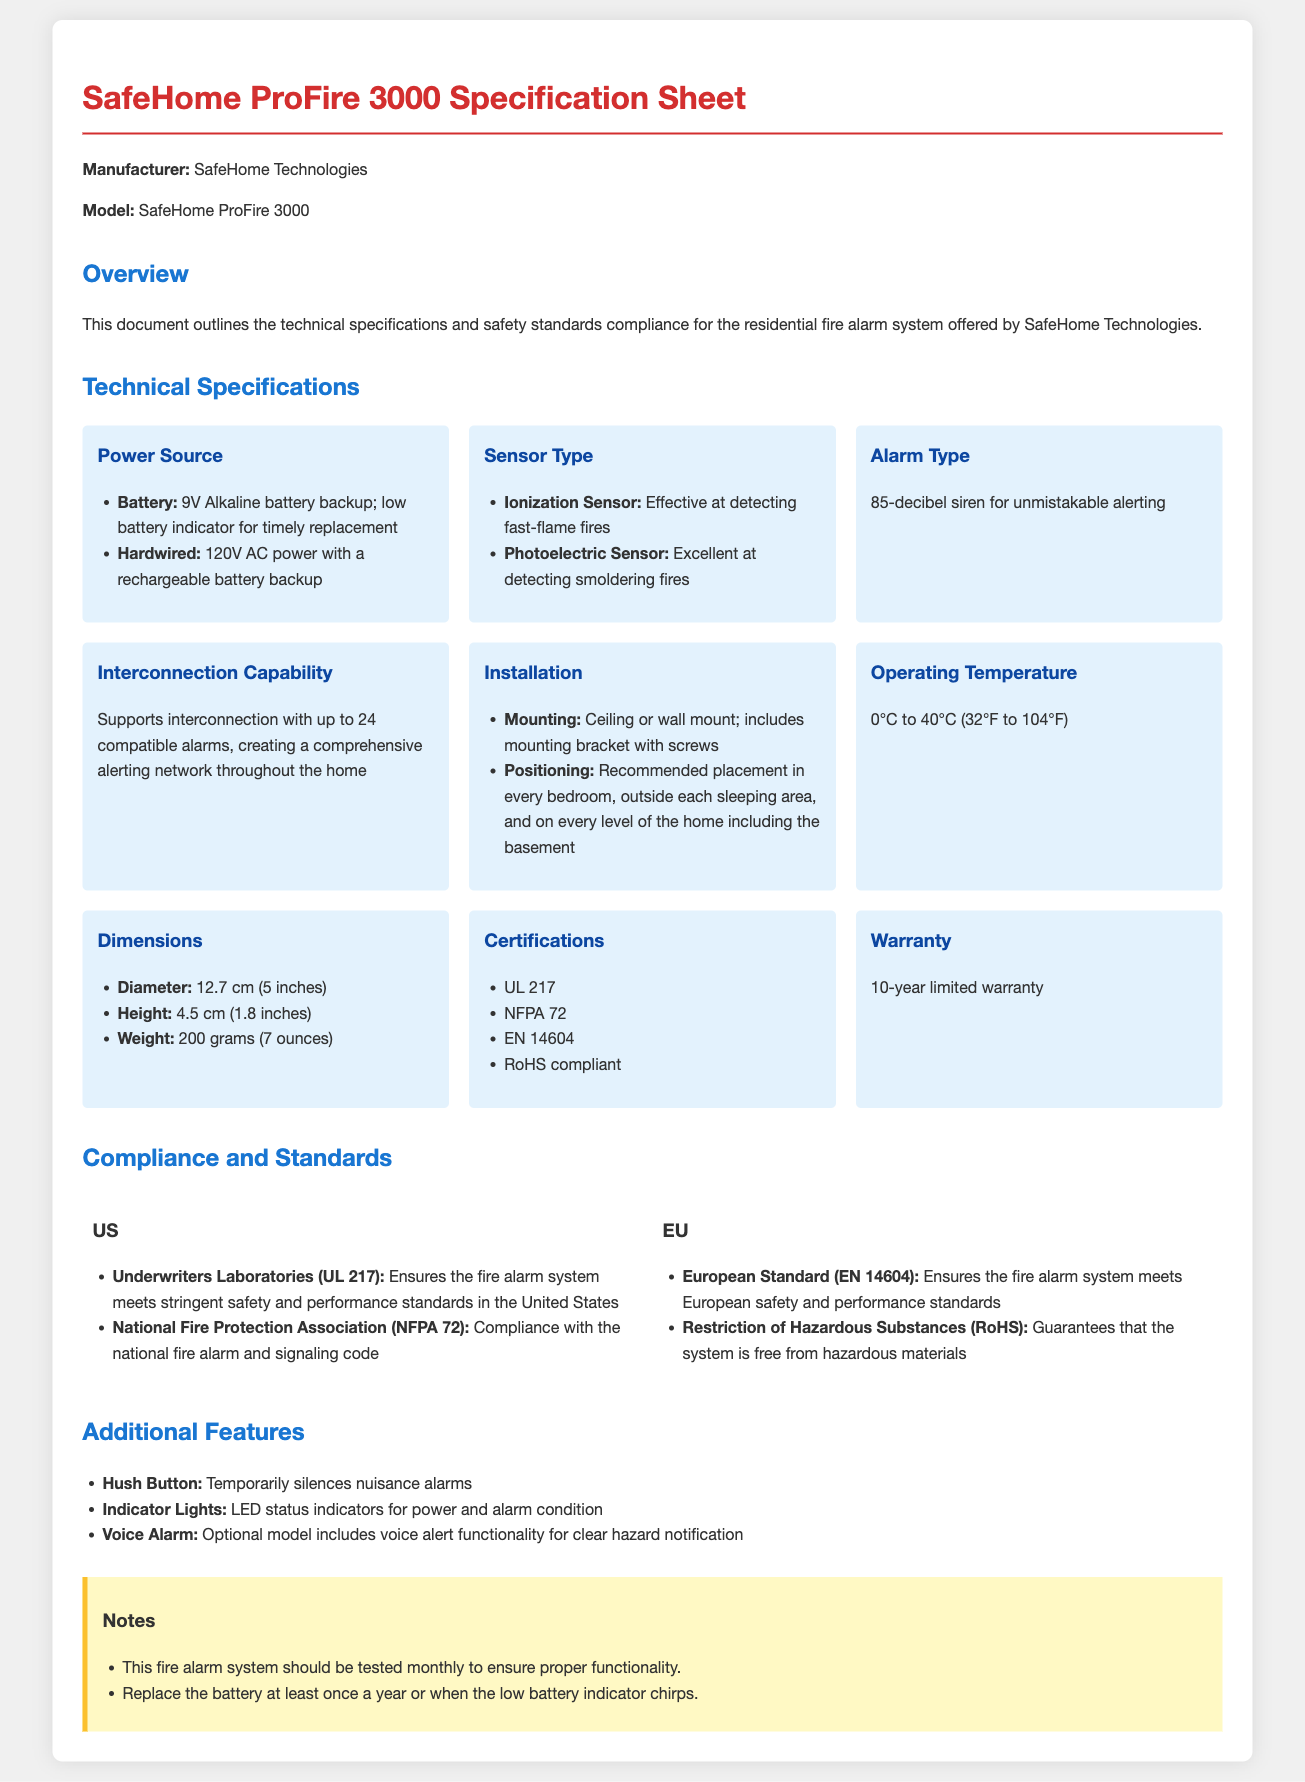What is the model name of the fire alarm system? The model name of the fire alarm system is found in the title of the document.
Answer: SafeHome ProFire 3000 What type of power source does the system use? The document lists both battery and hardwired power sources under technical specifications.
Answer: 9V Alkaline battery backup; 120V AC power What is the sound level of the alarm? The alarm type section specifies the decibel level of the siren.
Answer: 85-decibel siren How many alarms can be interconnected? The specification on interconnection capability provides the maximum number of alarms that can be linked.
Answer: 24 compatible alarms What is the operating temperature range? The operating temperature is mentioned in the technical specifications section of the document.
Answer: 0°C to 40°C Which certification ensures compliance with US safety standards? The compliance section lists relevant certifications for the US.
Answer: UL 217 What feature helps to temporarily silence nuisance alarms? The additional features section describes useful functionalities of the alarm.
Answer: Hush Button How long is the warranty period? The warranty information is stated in the technical specifications.
Answer: 10-year limited warranty What is the recommended placement for the alarm? The installation section mentions where the fire alarms should be positioned within the home.
Answer: Every bedroom, outside each sleeping area, and on every level of the home including the basement 